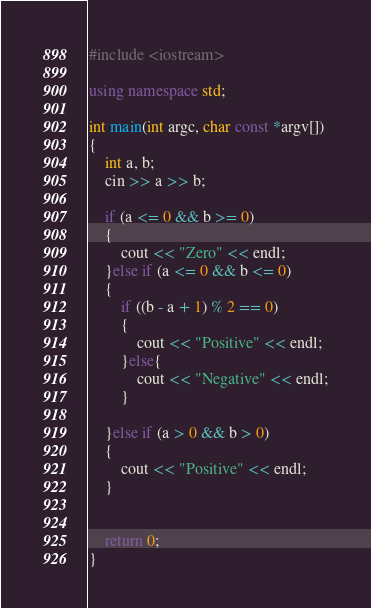Convert code to text. <code><loc_0><loc_0><loc_500><loc_500><_C++_>#include <iostream>

using namespace std;

int main(int argc, char const *argv[])
{
    int a, b;
    cin >> a >> b;

    if (a <= 0 && b >= 0)
    {
        cout << "Zero" << endl;
    }else if (a <= 0 && b <= 0)
    {
        if ((b - a + 1) % 2 == 0)
        {
            cout << "Positive" << endl;
        }else{
            cout << "Negative" << endl;
        }
        
    }else if (a > 0 && b > 0)
    {
        cout << "Positive" << endl;
    }
    
    
    return 0;
}
</code> 